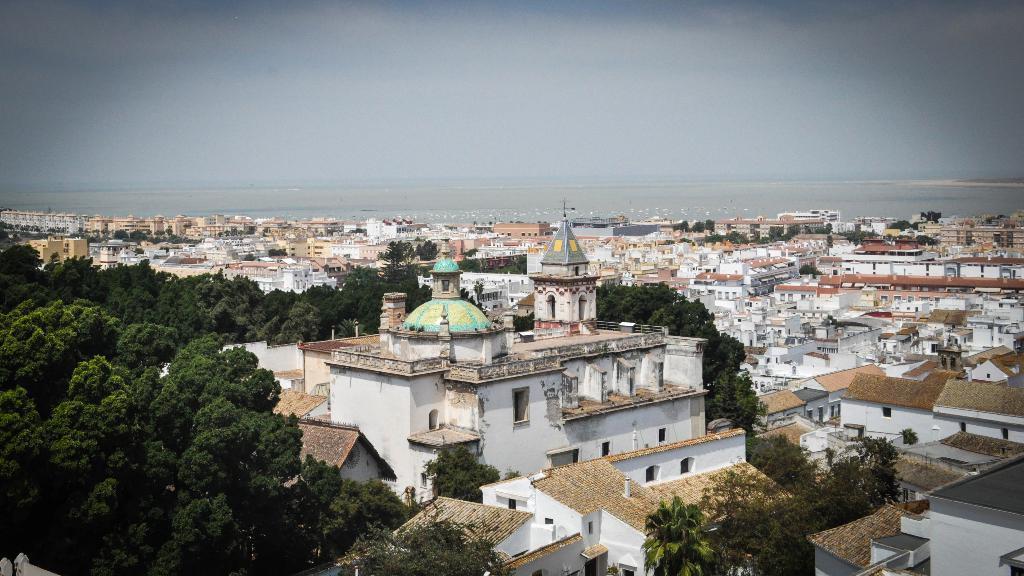Can you describe this image briefly? In this picture we can see trees, buildings, some objects and in the background we can see the sky. 